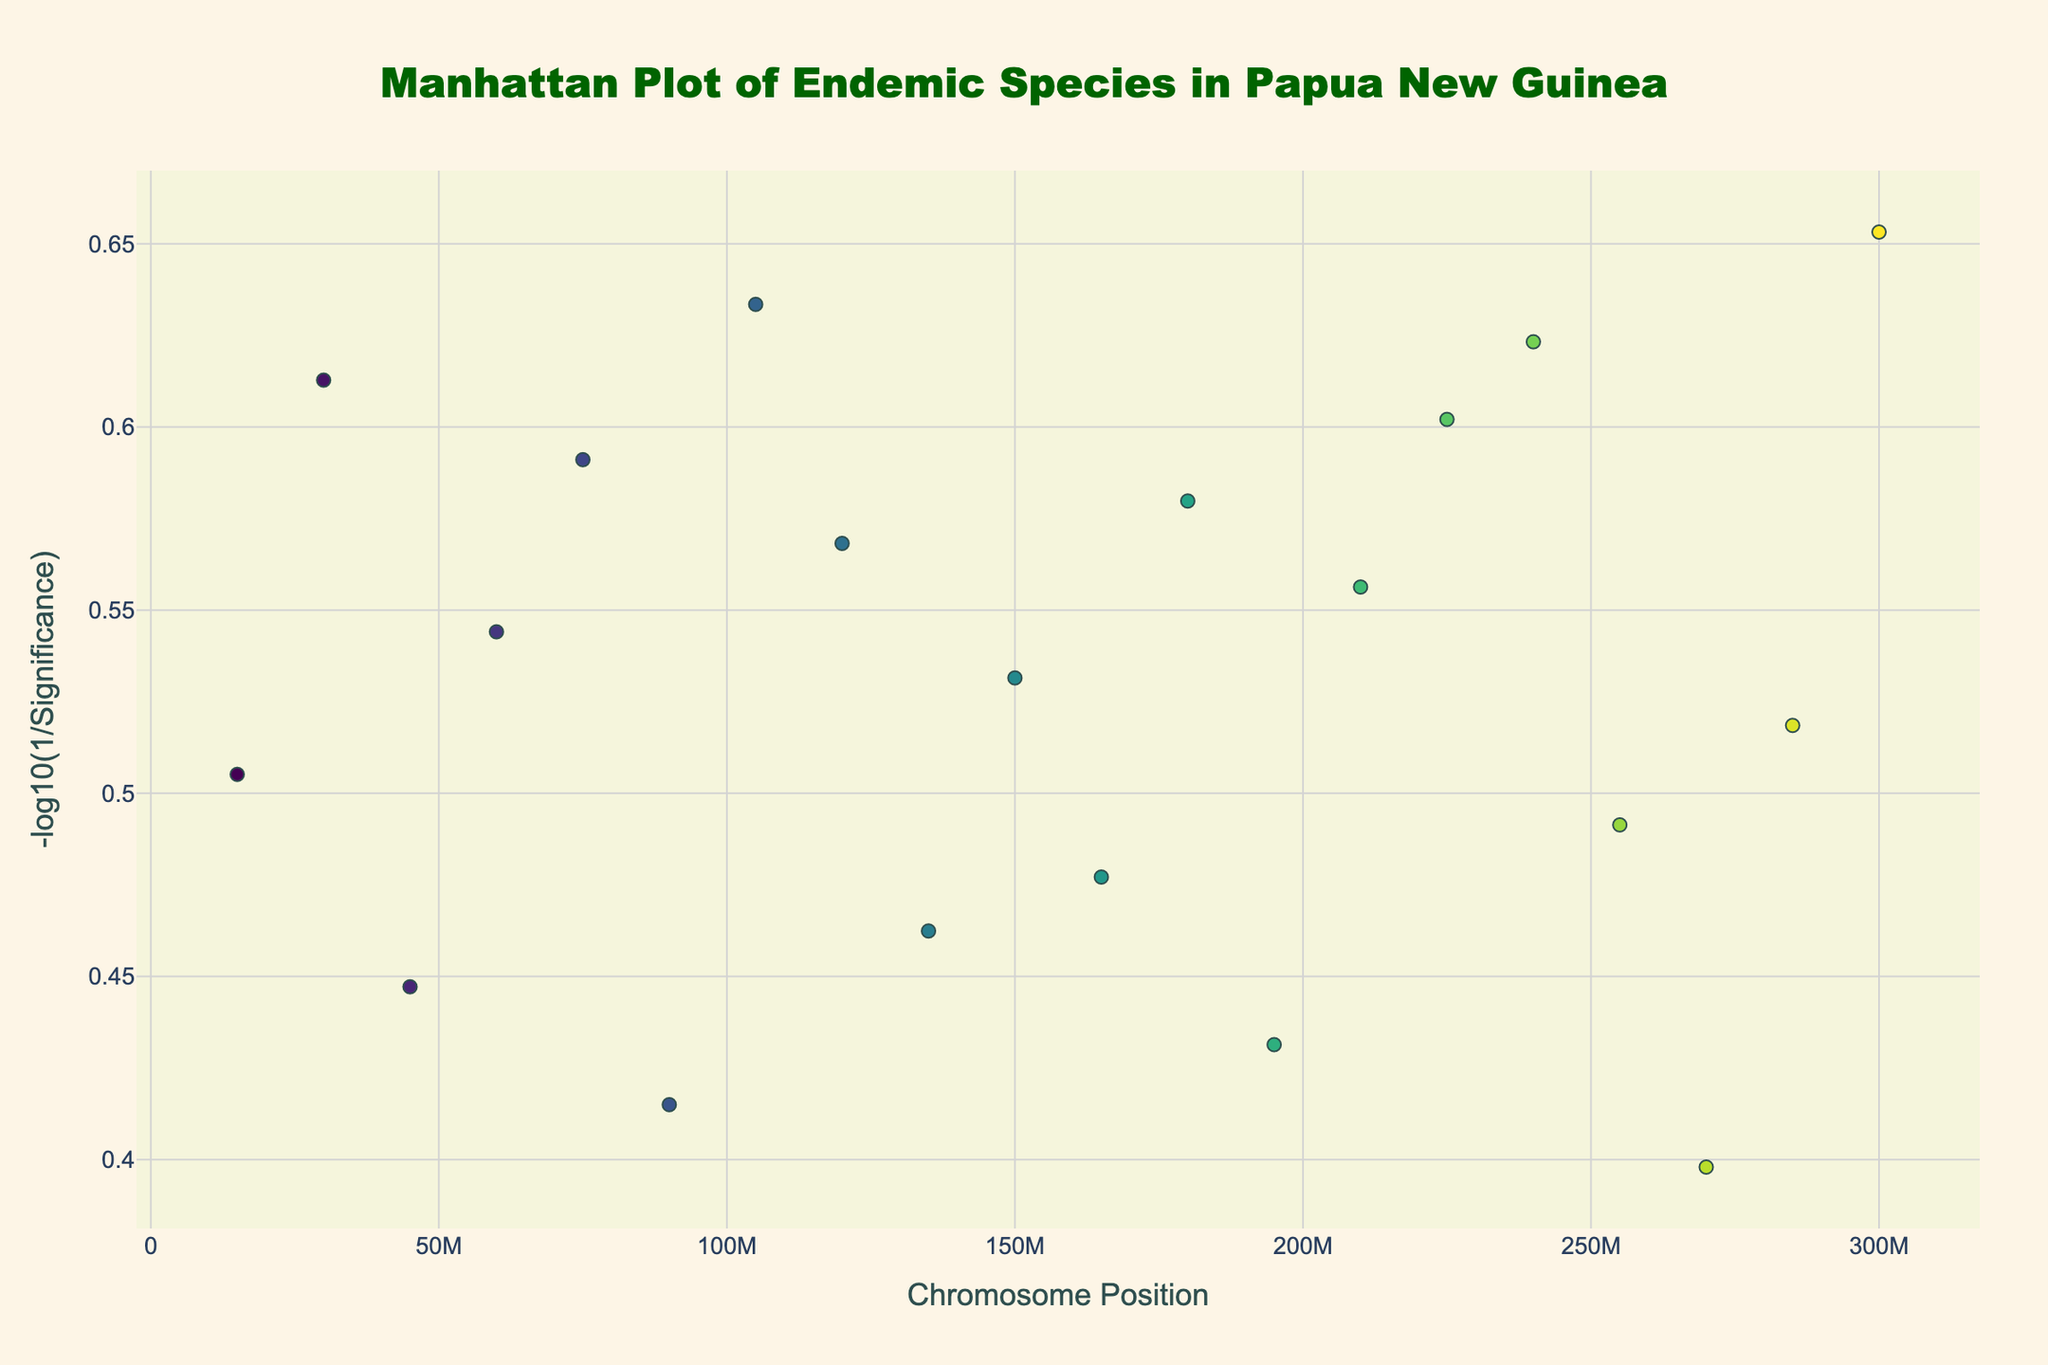What is the title of the figure? The title is usually located at the top center of the plot. For this one, it reads "Manhattan Plot of Endemic Species in Papua New Guinea".
Answer: Manhattan Plot of Endemic Species in Papua New Guinea What does the y-axis represent? The y-axis title is "-log10(1/Significance)". This indicates that the y-axis shows the negative logarithm to base 10 of the inverse of the significance value.
Answer: -log10(1/Significance) How many endemic species are represented in the plot? Each marker in the plot represents an endemic species, and there are 20 different markers in the data provided.
Answer: 20 Which species has the highest significance value? The highest point on the y-axis corresponds to the highest significance value. From the data, "Queen Alexandra's Birdwing" has the highest y-value of 4.5.
Answer: Queen Alexandra's Birdwing Which chromosome has the most significant data points clustered together in terms of position? Different chromosomes are color-coded, and the x-axis represents positions. Chromosome 1 appears to have multiple data points closely positioned around the 15,000,000 mark.
Answer: Chromosome 1 What is the lowest y-value on the plot and which endemic species does it correspond to? By looking at the plot for the lowest point on the y-axis, we see that "Papuan Whipbird" has the lowest significance value with a y-value of 2.5.
Answer: Papuan Whipbird What is the average significance value across all endemic species? To calculate the average, sum all significance values (3.2 + 4.1 + 2.8 + 3.5 + 3.9 + 2.6 + 4.3 + 3.7 + 2.9 + 3.4 + 3.0 + 3.8 + 2.7 + 3.6 + 4.0 + 4.2 + 3.1 + 2.5 + 3.3 + 4.5) and divide by the number of species (20). The total is 69.5, and the average is 69.5 / 20.
Answer: 3.475 Which chromosomes have species with a significance value greater than 4? Checking the data for species with significance values greater than 4, we find entries for chromosomes 2, 7, 16, and 20.
Answer: Chromosomes 2, 7, 16, 20 How many species have a significance value of at least 3.5? Counting through the significance values in the data, we see that 12 species have a significance value of 3.5 or higher.
Answer: 12 Which species is located at the highest chromosome position and what is its significance value? Scanning the data for the highest position, we find "Queen Alexandra's Birdwing" at position 300,000,000 with a significance value of 4.5.
Answer: Queen Alexandra's Birdwing, 4.5 